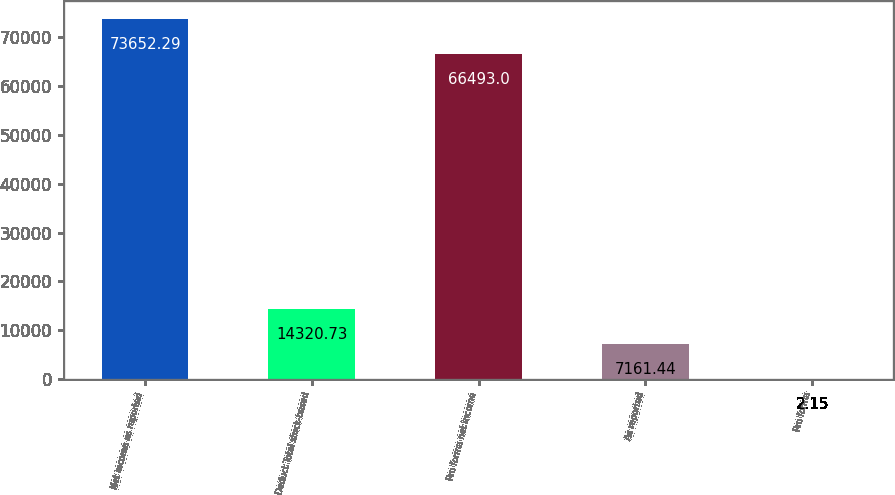<chart> <loc_0><loc_0><loc_500><loc_500><bar_chart><fcel>Net income as reported<fcel>Deduct Total stock-based<fcel>Pro forma net income<fcel>As reported<fcel>Pro forma<nl><fcel>73652.3<fcel>14320.7<fcel>66493<fcel>7161.44<fcel>2.15<nl></chart> 